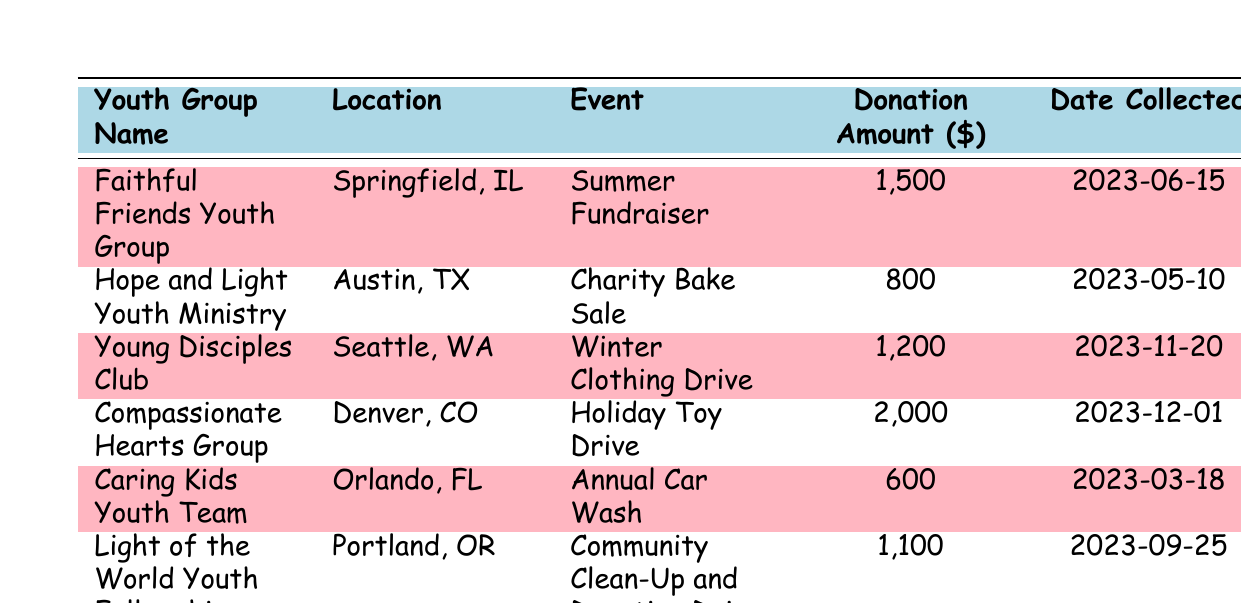What is the highest donation amount collected by a youth group? The highest donation amount can be identified by looking at the "Donation Amount" column. The maximum value in that column is 2000, associated with the "Compassionate Hearts Group."
Answer: 2000 Which youth group collected the least amount of donations? To find the least amount, we check the "Donation Amount" column and identify the smallest value, which is 600, belonging to the "Caring Kids Youth Team."
Answer: 600 How many events were held in total? By counting the number of rows in the table, we can determine the total number of events listed. There are 6 events organized by youth groups.
Answer: 6 What is the average donation amount collected across all youth groups? To find the average, we sum all the donation amounts: 1500 + 800 + 1200 + 2000 + 600 + 1100 = 6200. Then, we divide this sum by the number of groups (6). Thus, 6200 / 6 ≈ 1033.33.
Answer: 1033.33 Did any youth group collect donations before June 2023? By examining the "Date Collected" column, we can see that the "Caring Kids Youth Team" collected their donations on 2023-03-18, which is before June 2023.
Answer: Yes Which location had the event that generated the second highest donation amount? First, we order the amounts to find the second highest. The highest is 2000, and the next highest is 1500. The location corresponding to this second highest amount is "Springfield, IL" from the "Faithful Friends Youth Group."
Answer: Springfield, IL Is it true that all youth groups collected over 500 dollars? By checking each "Donation Amount," we see that all amounts are above 500: 1500, 800, 1200, 2000, 600, and 1100. Thus, the statement is true.
Answer: Yes What is the total amount of donations collected by the youth groups located in Texas? The only youth group from Texas is "Hope and Light Youth Ministry," which collected 800 dollars. Therefore, the total collected by Texas groups is 800.
Answer: 800 How many of the youth groups held events in the latter half of 2023? The events held in the latter half of 2023 are from "Young Disciples Club" (11-20), "Compassionate Hearts Group" (12-01), and "Light of the World Youth Fellowship" (09-25). Counting these shows there are 3 events in that timeframe.
Answer: 3 